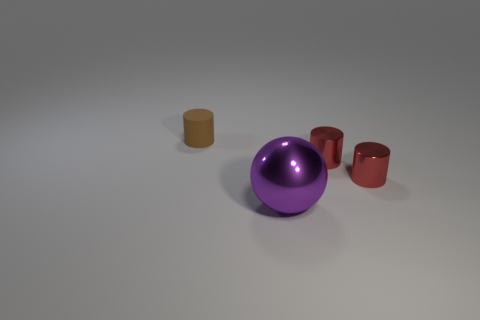Do the purple ball and the rubber thing have the same size?
Provide a succinct answer. No. How many things are either metal cylinders or matte cylinders?
Offer a terse response. 3. What is the size of the purple sphere?
Offer a very short reply. Large. What number of things are either metal things that are behind the metal sphere or small objects to the left of the big purple ball?
Your response must be concise. 3. The brown matte thing is what shape?
Offer a very short reply. Cylinder. What number of other small objects are the same material as the brown thing?
Provide a succinct answer. 0. The matte thing has what color?
Your response must be concise. Brown. What number of other things are the same size as the brown object?
Your answer should be very brief. 2. Is the number of purple balls on the left side of the purple object less than the number of purple balls in front of the tiny brown matte thing?
Offer a terse response. Yes. There is a sphere; is it the same size as the cylinder on the left side of the big object?
Provide a short and direct response. No. 